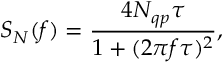<formula> <loc_0><loc_0><loc_500><loc_500>S _ { N } ( f ) = \frac { 4 N _ { q p } \tau } { 1 + ( 2 \pi f \tau ) ^ { 2 } } ,</formula> 